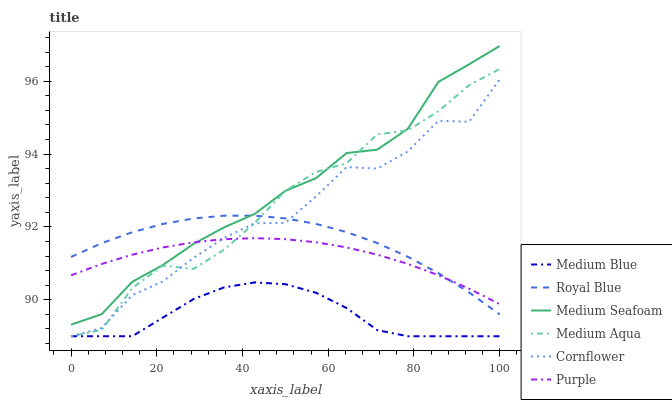Does Medium Blue have the minimum area under the curve?
Answer yes or no. Yes. Does Medium Seafoam have the maximum area under the curve?
Answer yes or no. Yes. Does Purple have the minimum area under the curve?
Answer yes or no. No. Does Purple have the maximum area under the curve?
Answer yes or no. No. Is Purple the smoothest?
Answer yes or no. Yes. Is Cornflower the roughest?
Answer yes or no. Yes. Is Medium Blue the smoothest?
Answer yes or no. No. Is Medium Blue the roughest?
Answer yes or no. No. Does Cornflower have the lowest value?
Answer yes or no. Yes. Does Purple have the lowest value?
Answer yes or no. No. Does Medium Seafoam have the highest value?
Answer yes or no. Yes. Does Purple have the highest value?
Answer yes or no. No. Is Medium Blue less than Medium Seafoam?
Answer yes or no. Yes. Is Royal Blue greater than Medium Blue?
Answer yes or no. Yes. Does Purple intersect Cornflower?
Answer yes or no. Yes. Is Purple less than Cornflower?
Answer yes or no. No. Is Purple greater than Cornflower?
Answer yes or no. No. Does Medium Blue intersect Medium Seafoam?
Answer yes or no. No. 